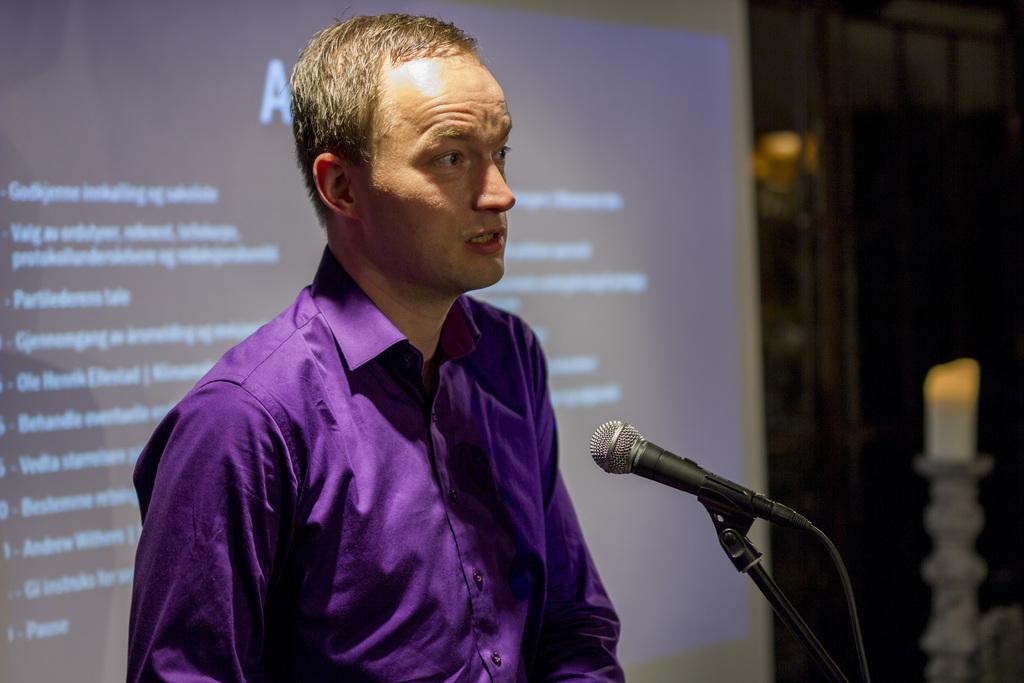What is the main subject of the image? The main subject of the image is a man standing in the center. What is the man doing in the image? The man is standing in front of a mic. What can be seen in the background of the image? There is a screen in the background of the image. What is written on the screen? There is text written on the screen. What type of love can be seen on the board in the image? There is no board or love present in the image. How does the heat affect the man in the image? There is no mention of heat or its effects in the image. 